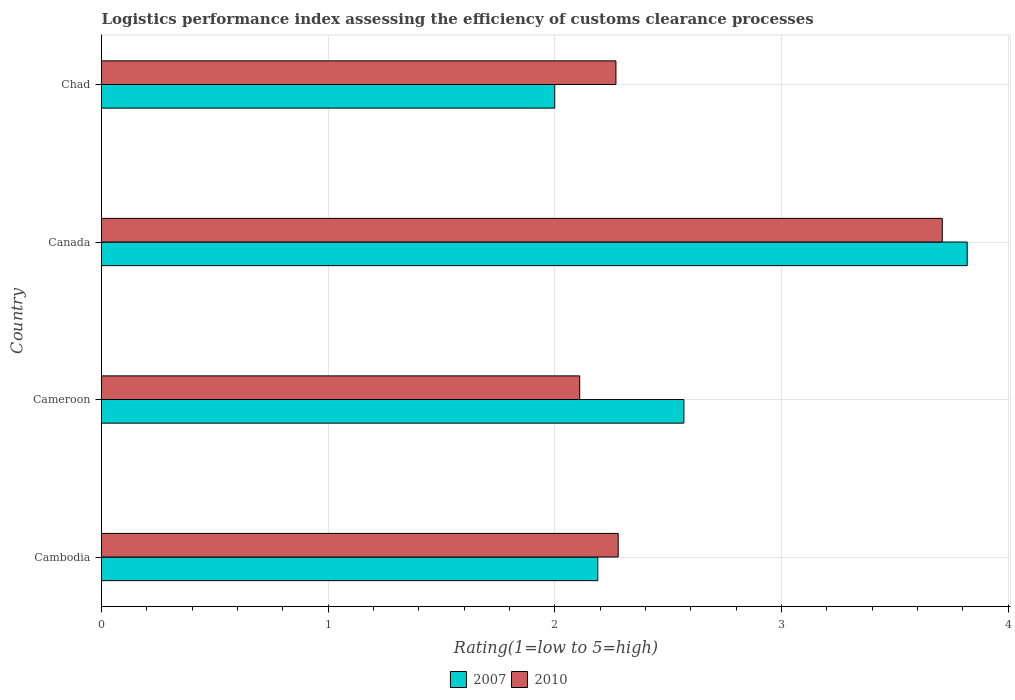Are the number of bars per tick equal to the number of legend labels?
Provide a succinct answer. Yes. What is the label of the 2nd group of bars from the top?
Give a very brief answer. Canada. What is the Logistic performance index in 2010 in Canada?
Offer a terse response. 3.71. Across all countries, what is the maximum Logistic performance index in 2010?
Provide a short and direct response. 3.71. Across all countries, what is the minimum Logistic performance index in 2010?
Provide a short and direct response. 2.11. In which country was the Logistic performance index in 2007 minimum?
Keep it short and to the point. Chad. What is the total Logistic performance index in 2010 in the graph?
Your response must be concise. 10.37. What is the difference between the Logistic performance index in 2007 in Cameroon and that in Canada?
Give a very brief answer. -1.25. What is the difference between the Logistic performance index in 2007 in Cameroon and the Logistic performance index in 2010 in Canada?
Offer a terse response. -1.14. What is the average Logistic performance index in 2007 per country?
Keep it short and to the point. 2.65. What is the difference between the Logistic performance index in 2010 and Logistic performance index in 2007 in Cameroon?
Ensure brevity in your answer.  -0.46. In how many countries, is the Logistic performance index in 2007 greater than 2.6 ?
Give a very brief answer. 1. What is the ratio of the Logistic performance index in 2007 in Canada to that in Chad?
Give a very brief answer. 1.91. Is the Logistic performance index in 2010 in Canada less than that in Chad?
Ensure brevity in your answer.  No. What is the difference between the highest and the second highest Logistic performance index in 2010?
Make the answer very short. 1.43. In how many countries, is the Logistic performance index in 2010 greater than the average Logistic performance index in 2010 taken over all countries?
Offer a terse response. 1. Is the sum of the Logistic performance index in 2010 in Cambodia and Cameroon greater than the maximum Logistic performance index in 2007 across all countries?
Make the answer very short. Yes. What does the 2nd bar from the bottom in Cambodia represents?
Your answer should be compact. 2010. How many bars are there?
Offer a very short reply. 8. Are all the bars in the graph horizontal?
Keep it short and to the point. Yes. What is the difference between two consecutive major ticks on the X-axis?
Your answer should be compact. 1. Are the values on the major ticks of X-axis written in scientific E-notation?
Offer a terse response. No. Does the graph contain any zero values?
Ensure brevity in your answer.  No. Does the graph contain grids?
Your answer should be compact. Yes. How are the legend labels stacked?
Give a very brief answer. Horizontal. What is the title of the graph?
Offer a very short reply. Logistics performance index assessing the efficiency of customs clearance processes. Does "2012" appear as one of the legend labels in the graph?
Your response must be concise. No. What is the label or title of the X-axis?
Keep it short and to the point. Rating(1=low to 5=high). What is the Rating(1=low to 5=high) of 2007 in Cambodia?
Offer a very short reply. 2.19. What is the Rating(1=low to 5=high) in 2010 in Cambodia?
Your answer should be very brief. 2.28. What is the Rating(1=low to 5=high) in 2007 in Cameroon?
Offer a very short reply. 2.57. What is the Rating(1=low to 5=high) in 2010 in Cameroon?
Make the answer very short. 2.11. What is the Rating(1=low to 5=high) in 2007 in Canada?
Your answer should be compact. 3.82. What is the Rating(1=low to 5=high) of 2010 in Canada?
Your response must be concise. 3.71. What is the Rating(1=low to 5=high) of 2010 in Chad?
Your response must be concise. 2.27. Across all countries, what is the maximum Rating(1=low to 5=high) in 2007?
Your answer should be compact. 3.82. Across all countries, what is the maximum Rating(1=low to 5=high) of 2010?
Provide a succinct answer. 3.71. Across all countries, what is the minimum Rating(1=low to 5=high) of 2007?
Offer a very short reply. 2. Across all countries, what is the minimum Rating(1=low to 5=high) of 2010?
Provide a short and direct response. 2.11. What is the total Rating(1=low to 5=high) of 2007 in the graph?
Make the answer very short. 10.58. What is the total Rating(1=low to 5=high) of 2010 in the graph?
Keep it short and to the point. 10.37. What is the difference between the Rating(1=low to 5=high) of 2007 in Cambodia and that in Cameroon?
Keep it short and to the point. -0.38. What is the difference between the Rating(1=low to 5=high) in 2010 in Cambodia and that in Cameroon?
Keep it short and to the point. 0.17. What is the difference between the Rating(1=low to 5=high) in 2007 in Cambodia and that in Canada?
Make the answer very short. -1.63. What is the difference between the Rating(1=low to 5=high) in 2010 in Cambodia and that in Canada?
Your answer should be very brief. -1.43. What is the difference between the Rating(1=low to 5=high) of 2007 in Cambodia and that in Chad?
Offer a terse response. 0.19. What is the difference between the Rating(1=low to 5=high) of 2007 in Cameroon and that in Canada?
Your answer should be very brief. -1.25. What is the difference between the Rating(1=low to 5=high) in 2007 in Cameroon and that in Chad?
Your answer should be very brief. 0.57. What is the difference between the Rating(1=low to 5=high) of 2010 in Cameroon and that in Chad?
Provide a succinct answer. -0.16. What is the difference between the Rating(1=low to 5=high) of 2007 in Canada and that in Chad?
Ensure brevity in your answer.  1.82. What is the difference between the Rating(1=low to 5=high) in 2010 in Canada and that in Chad?
Offer a very short reply. 1.44. What is the difference between the Rating(1=low to 5=high) of 2007 in Cambodia and the Rating(1=low to 5=high) of 2010 in Cameroon?
Give a very brief answer. 0.08. What is the difference between the Rating(1=low to 5=high) of 2007 in Cambodia and the Rating(1=low to 5=high) of 2010 in Canada?
Ensure brevity in your answer.  -1.52. What is the difference between the Rating(1=low to 5=high) in 2007 in Cambodia and the Rating(1=low to 5=high) in 2010 in Chad?
Ensure brevity in your answer.  -0.08. What is the difference between the Rating(1=low to 5=high) in 2007 in Cameroon and the Rating(1=low to 5=high) in 2010 in Canada?
Offer a very short reply. -1.14. What is the difference between the Rating(1=low to 5=high) in 2007 in Canada and the Rating(1=low to 5=high) in 2010 in Chad?
Keep it short and to the point. 1.55. What is the average Rating(1=low to 5=high) in 2007 per country?
Give a very brief answer. 2.65. What is the average Rating(1=low to 5=high) in 2010 per country?
Provide a succinct answer. 2.59. What is the difference between the Rating(1=low to 5=high) of 2007 and Rating(1=low to 5=high) of 2010 in Cambodia?
Offer a terse response. -0.09. What is the difference between the Rating(1=low to 5=high) in 2007 and Rating(1=low to 5=high) in 2010 in Cameroon?
Offer a very short reply. 0.46. What is the difference between the Rating(1=low to 5=high) of 2007 and Rating(1=low to 5=high) of 2010 in Canada?
Provide a succinct answer. 0.11. What is the difference between the Rating(1=low to 5=high) of 2007 and Rating(1=low to 5=high) of 2010 in Chad?
Make the answer very short. -0.27. What is the ratio of the Rating(1=low to 5=high) of 2007 in Cambodia to that in Cameroon?
Make the answer very short. 0.85. What is the ratio of the Rating(1=low to 5=high) in 2010 in Cambodia to that in Cameroon?
Provide a succinct answer. 1.08. What is the ratio of the Rating(1=low to 5=high) of 2007 in Cambodia to that in Canada?
Provide a short and direct response. 0.57. What is the ratio of the Rating(1=low to 5=high) of 2010 in Cambodia to that in Canada?
Make the answer very short. 0.61. What is the ratio of the Rating(1=low to 5=high) of 2007 in Cambodia to that in Chad?
Offer a very short reply. 1.09. What is the ratio of the Rating(1=low to 5=high) in 2010 in Cambodia to that in Chad?
Make the answer very short. 1. What is the ratio of the Rating(1=low to 5=high) of 2007 in Cameroon to that in Canada?
Give a very brief answer. 0.67. What is the ratio of the Rating(1=low to 5=high) in 2010 in Cameroon to that in Canada?
Provide a short and direct response. 0.57. What is the ratio of the Rating(1=low to 5=high) in 2007 in Cameroon to that in Chad?
Provide a short and direct response. 1.28. What is the ratio of the Rating(1=low to 5=high) in 2010 in Cameroon to that in Chad?
Provide a short and direct response. 0.93. What is the ratio of the Rating(1=low to 5=high) of 2007 in Canada to that in Chad?
Provide a succinct answer. 1.91. What is the ratio of the Rating(1=low to 5=high) of 2010 in Canada to that in Chad?
Your response must be concise. 1.63. What is the difference between the highest and the second highest Rating(1=low to 5=high) in 2007?
Make the answer very short. 1.25. What is the difference between the highest and the second highest Rating(1=low to 5=high) of 2010?
Keep it short and to the point. 1.43. What is the difference between the highest and the lowest Rating(1=low to 5=high) in 2007?
Give a very brief answer. 1.82. What is the difference between the highest and the lowest Rating(1=low to 5=high) in 2010?
Make the answer very short. 1.6. 